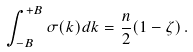Convert formula to latex. <formula><loc_0><loc_0><loc_500><loc_500>\int _ { - B } ^ { + B } \sigma ( k ) d k = \frac { n } { 2 } ( 1 - \zeta ) \, .</formula> 